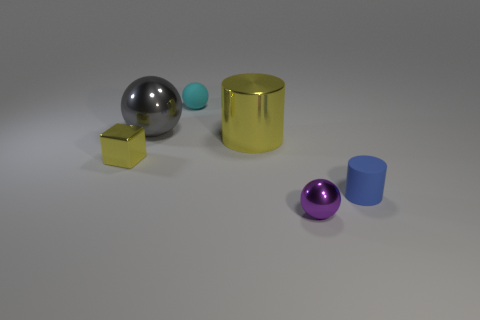Are there any big cyan blocks made of the same material as the purple ball?
Provide a succinct answer. No. There is a small object that is the same color as the metallic cylinder; what is its material?
Your answer should be very brief. Metal. Does the tiny thing in front of the blue matte thing have the same material as the cylinder that is left of the blue object?
Offer a very short reply. Yes. Is the number of small blue rubber objects greater than the number of red rubber objects?
Ensure brevity in your answer.  Yes. What is the color of the tiny ball in front of the rubber thing right of the metal ball that is in front of the small yellow shiny block?
Offer a terse response. Purple. Does the cylinder behind the cube have the same color as the small shiny object that is behind the small blue matte object?
Make the answer very short. Yes. There is a large object right of the cyan thing; how many cyan rubber things are right of it?
Make the answer very short. 0. Are any cyan matte things visible?
Provide a short and direct response. Yes. How many other objects are there of the same color as the cube?
Keep it short and to the point. 1. Is the number of purple things less than the number of balls?
Keep it short and to the point. Yes. 